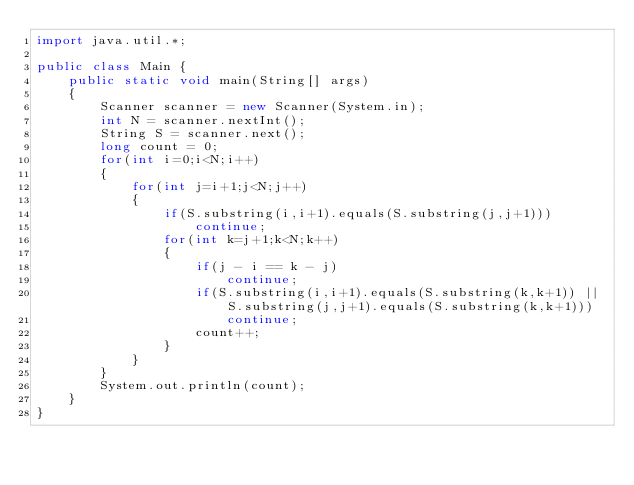<code> <loc_0><loc_0><loc_500><loc_500><_Java_>import java.util.*;

public class Main {
    public static void main(String[] args)
    {
        Scanner scanner = new Scanner(System.in);
        int N = scanner.nextInt();
        String S = scanner.next();
        long count = 0;
        for(int i=0;i<N;i++)
        {
            for(int j=i+1;j<N;j++)
            {
                if(S.substring(i,i+1).equals(S.substring(j,j+1)))
                    continue;
                for(int k=j+1;k<N;k++)
                {
                    if(j - i == k - j)
                        continue;
                    if(S.substring(i,i+1).equals(S.substring(k,k+1)) || S.substring(j,j+1).equals(S.substring(k,k+1)))
                        continue;
                    count++;
                }
            }
        }
        System.out.println(count);
    }
}
</code> 